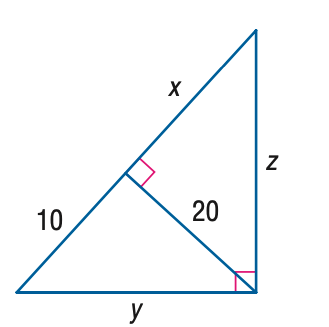Answer the mathemtical geometry problem and directly provide the correct option letter.
Question: Find x.
Choices: A: 10 B: 10 \sqrt { 2 } C: 20 D: 40 D 